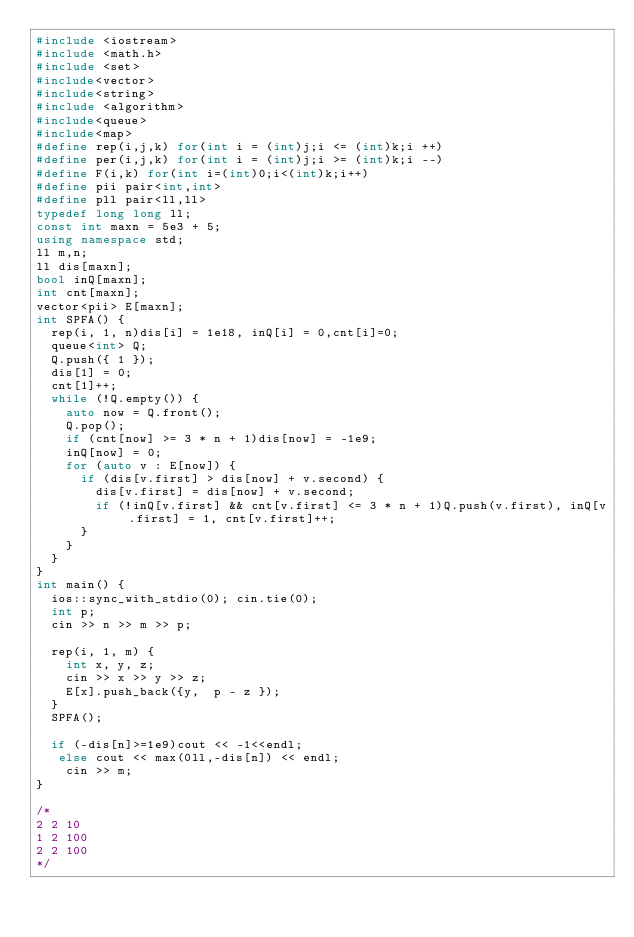Convert code to text. <code><loc_0><loc_0><loc_500><loc_500><_C++_>#include <iostream>
#include <math.h>
#include <set>
#include<vector>
#include<string>
#include <algorithm>
#include<queue>
#include<map>
#define rep(i,j,k) for(int i = (int)j;i <= (int)k;i ++)
#define per(i,j,k) for(int i = (int)j;i >= (int)k;i --)
#define F(i,k) for(int i=(int)0;i<(int)k;i++)
#define pii pair<int,int>
#define pll pair<ll,ll>
typedef long long ll;
const int maxn = 5e3 + 5;
using namespace std;
ll m,n;
ll dis[maxn];
bool inQ[maxn];
int cnt[maxn];
vector<pii> E[maxn];
int SPFA() {
	rep(i, 1, n)dis[i] = 1e18, inQ[i] = 0,cnt[i]=0;
	queue<int> Q;
	Q.push({ 1 });
	dis[1] = 0;
	cnt[1]++;
	while (!Q.empty()) {
		auto now = Q.front();
		Q.pop();
		if (cnt[now] >= 3 * n + 1)dis[now] = -1e9;
		inQ[now] = 0;
		for (auto v : E[now]) {
			if (dis[v.first] > dis[now] + v.second) {
				dis[v.first] = dis[now] + v.second;
				if (!inQ[v.first] && cnt[v.first] <= 3 * n + 1)Q.push(v.first), inQ[v.first] = 1, cnt[v.first]++;
			}
		}
	}
}
int main() {
	ios::sync_with_stdio(0); cin.tie(0);
	int p;
	cin >> n >> m >> p;

	rep(i, 1, m) {
		int x, y, z;
		cin >> x >> y >> z;
		E[x].push_back({y,  p - z });
	}
	SPFA();
	
	if (-dis[n]>=1e9)cout << -1<<endl;
	 else cout << max(0ll,-dis[n]) << endl;
		cin >> m;
}

/*
2 2 10
1 2 100
2 2 100
*/</code> 